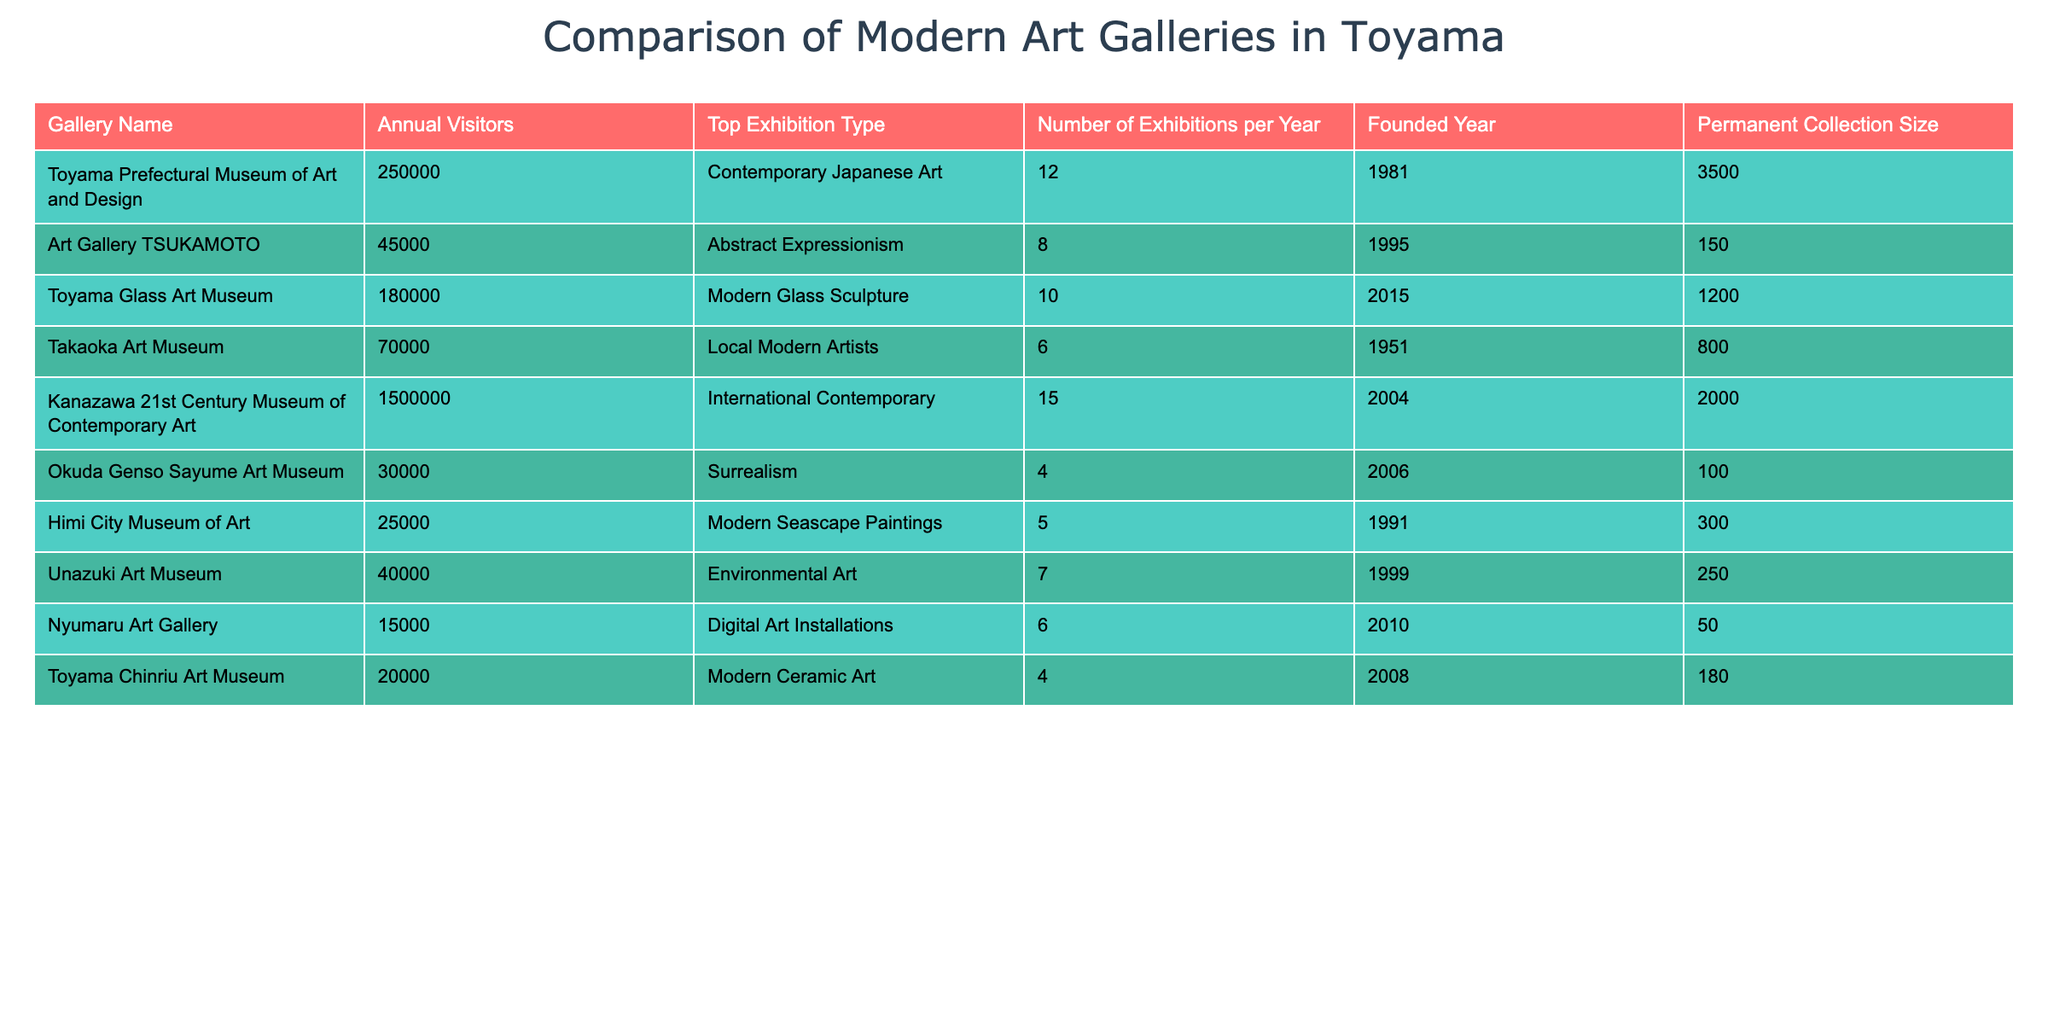What is the top exhibition type for Toyama Prefectural Museum of Art and Design? The table shows the "Top Exhibition Type" column for the Toyama Prefectural Museum of Art and Design, which is "Contemporary Japanese Art."
Answer: Contemporary Japanese Art How many exhibitions does Art Gallery TSUKAMOTO have per year? By looking at the "Number of Exhibitions per Year" column for the Art Gallery TSUKAMOTO, it indicates that there are 8 exhibitions per year.
Answer: 8 Is the Toyama Glass Art Museum founded after 2000? Checking the "Founded Year" of the Toyama Glass Art Museum, which is 2015, confirms that it was founded after 2000.
Answer: Yes Which gallery has the highest annual visitors? The "Annual Visitors" column shows that the gallery with the highest number of visitors is the Kanazawa 21st Century Museum of Contemporary Art, with 1,500,000 visitors.
Answer: Kanazawa 21st Century Museum of Contemporary Art What is the average number of exhibitions per year across all galleries? To find the average number of exhibitions, we need to add the values from the "Number of Exhibitions per Year" column (12 + 8 + 10 + 6 + 15 + 4 + 5 + 7 + 6 + 4 = 77) and divide by the total number of galleries (10). Therefore, the average is 77/10 = 7.7.
Answer: 7.7 How many galleries have a permanent collection size larger than 500? By examining the "Permanent Collection Size" column, the galleries with sizes larger than 500 are: Toyama Prefectural Museum of Art and Design (3500), Kanazawa 21st Century Museum of Contemporary Art (2000), and Takaoka Art Museum (800), totaling 3 galleries.
Answer: 3 Does the Himi City Museum of Art have more annual visitors than Unazuki Art Museum? The annual visitors for Himi City Museum of Art is 25,000 and for Unazuki Art Museum is 40,000. Since 25,000 is less than 40,000, the Himi City Museum of Art does not have more visitors.
Answer: No If you combine the annual visitors of Toyama Chinriu Art Museum and Nyumaru Art Gallery, do they exceed the visitors of Art Gallery TSUKAMOTO? The annual visitors for Toyama Chinriu Art Museum is 20,000, and for Nyumaru Art Gallery it is 15,000. Added together, they total 35,000, which is less than the 45,000 visitors of Art Gallery TSUKAMOTO.
Answer: No 